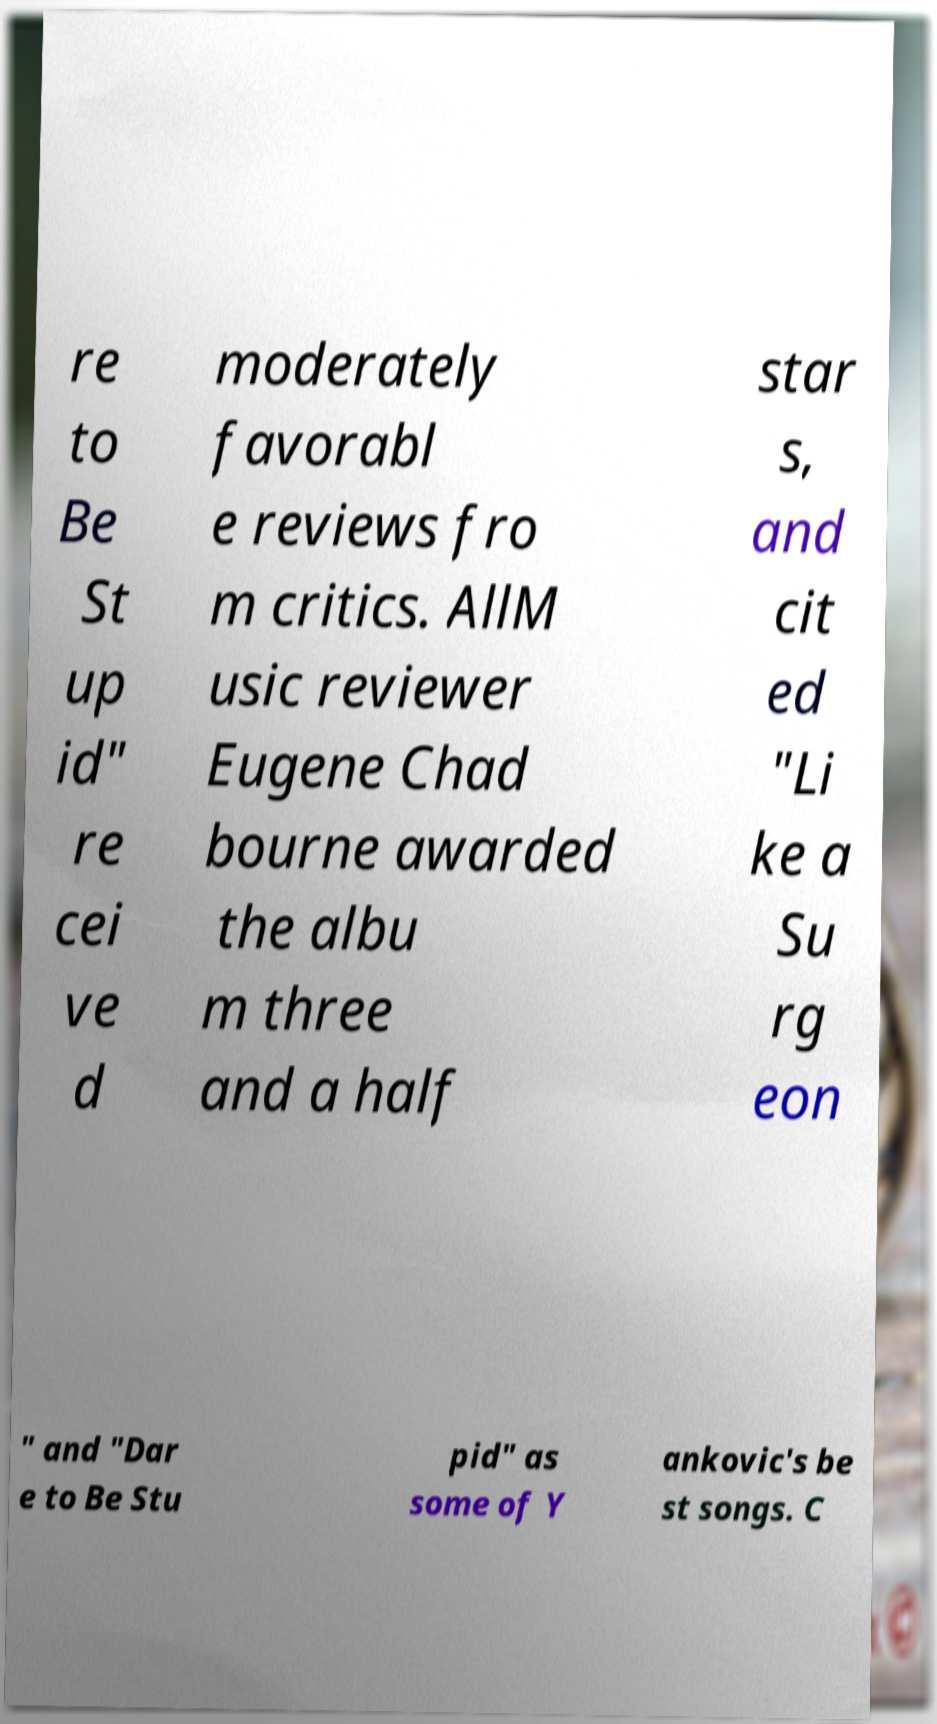For documentation purposes, I need the text within this image transcribed. Could you provide that? re to Be St up id" re cei ve d moderately favorabl e reviews fro m critics. AllM usic reviewer Eugene Chad bourne awarded the albu m three and a half star s, and cit ed "Li ke a Su rg eon " and "Dar e to Be Stu pid" as some of Y ankovic's be st songs. C 